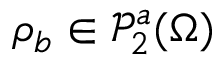Convert formula to latex. <formula><loc_0><loc_0><loc_500><loc_500>\rho _ { b } \in \ m a t h s c r { P } _ { 2 } ^ { a } ( \Omega )</formula> 